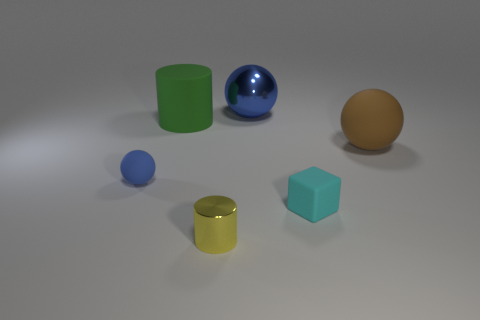Add 4 cylinders. How many objects exist? 10 Subtract all blocks. How many objects are left? 5 Add 3 tiny cyan cylinders. How many tiny cyan cylinders exist? 3 Subtract 0 gray cylinders. How many objects are left? 6 Subtract all large green rubber spheres. Subtract all metallic objects. How many objects are left? 4 Add 2 blocks. How many blocks are left? 3 